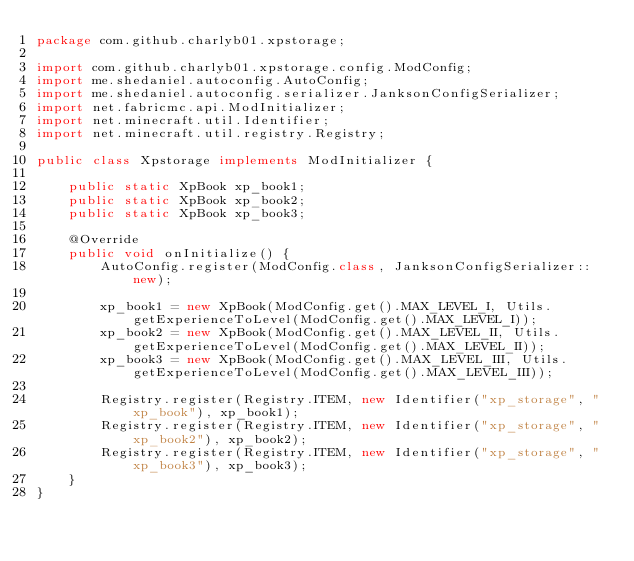<code> <loc_0><loc_0><loc_500><loc_500><_Java_>package com.github.charlyb01.xpstorage;

import com.github.charlyb01.xpstorage.config.ModConfig;
import me.shedaniel.autoconfig.AutoConfig;
import me.shedaniel.autoconfig.serializer.JanksonConfigSerializer;
import net.fabricmc.api.ModInitializer;
import net.minecraft.util.Identifier;
import net.minecraft.util.registry.Registry;

public class Xpstorage implements ModInitializer {

    public static XpBook xp_book1;
    public static XpBook xp_book2;
    public static XpBook xp_book3;

    @Override
    public void onInitialize() {
        AutoConfig.register(ModConfig.class, JanksonConfigSerializer::new);

        xp_book1 = new XpBook(ModConfig.get().MAX_LEVEL_I, Utils.getExperienceToLevel(ModConfig.get().MAX_LEVEL_I));
        xp_book2 = new XpBook(ModConfig.get().MAX_LEVEL_II, Utils.getExperienceToLevel(ModConfig.get().MAX_LEVEL_II));
        xp_book3 = new XpBook(ModConfig.get().MAX_LEVEL_III, Utils.getExperienceToLevel(ModConfig.get().MAX_LEVEL_III));

        Registry.register(Registry.ITEM, new Identifier("xp_storage", "xp_book"), xp_book1);
        Registry.register(Registry.ITEM, new Identifier("xp_storage", "xp_book2"), xp_book2);
        Registry.register(Registry.ITEM, new Identifier("xp_storage", "xp_book3"), xp_book3);
    }
}
</code> 